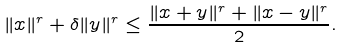<formula> <loc_0><loc_0><loc_500><loc_500>\| x \| ^ { r } + \delta \| y \| ^ { r } \leq \frac { \| x + y \| ^ { r } + \| x - y \| ^ { r } } { 2 } .</formula> 